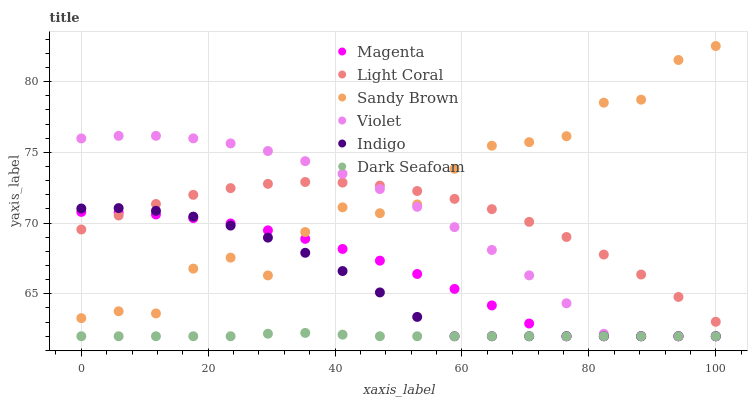Does Dark Seafoam have the minimum area under the curve?
Answer yes or no. Yes. Does Sandy Brown have the maximum area under the curve?
Answer yes or no. Yes. Does Light Coral have the minimum area under the curve?
Answer yes or no. No. Does Light Coral have the maximum area under the curve?
Answer yes or no. No. Is Dark Seafoam the smoothest?
Answer yes or no. Yes. Is Sandy Brown the roughest?
Answer yes or no. Yes. Is Light Coral the smoothest?
Answer yes or no. No. Is Light Coral the roughest?
Answer yes or no. No. Does Indigo have the lowest value?
Answer yes or no. Yes. Does Light Coral have the lowest value?
Answer yes or no. No. Does Sandy Brown have the highest value?
Answer yes or no. Yes. Does Light Coral have the highest value?
Answer yes or no. No. Is Dark Seafoam less than Sandy Brown?
Answer yes or no. Yes. Is Sandy Brown greater than Dark Seafoam?
Answer yes or no. Yes. Does Indigo intersect Magenta?
Answer yes or no. Yes. Is Indigo less than Magenta?
Answer yes or no. No. Is Indigo greater than Magenta?
Answer yes or no. No. Does Dark Seafoam intersect Sandy Brown?
Answer yes or no. No. 